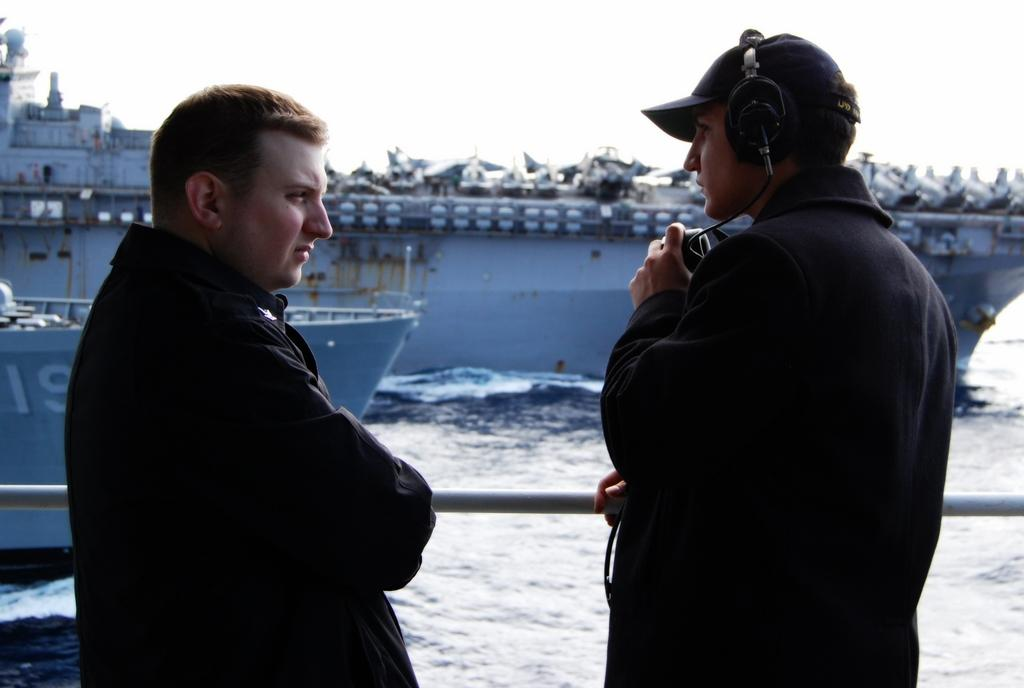Where was the image taken? The image was clicked outside the city. What can be seen in the foreground of the image? There are two people standing in the foreground. What is the main feature in the center of the image? There are ships in a water body in the center of the image. What is visible in the background of the image? The sky is visible in the background of the image. How many chickens are there in the image? There are no chickens present in the image. What type of servant can be seen attending to the people in the image? There is no servant present in the image; only two people are visible in the foreground. 